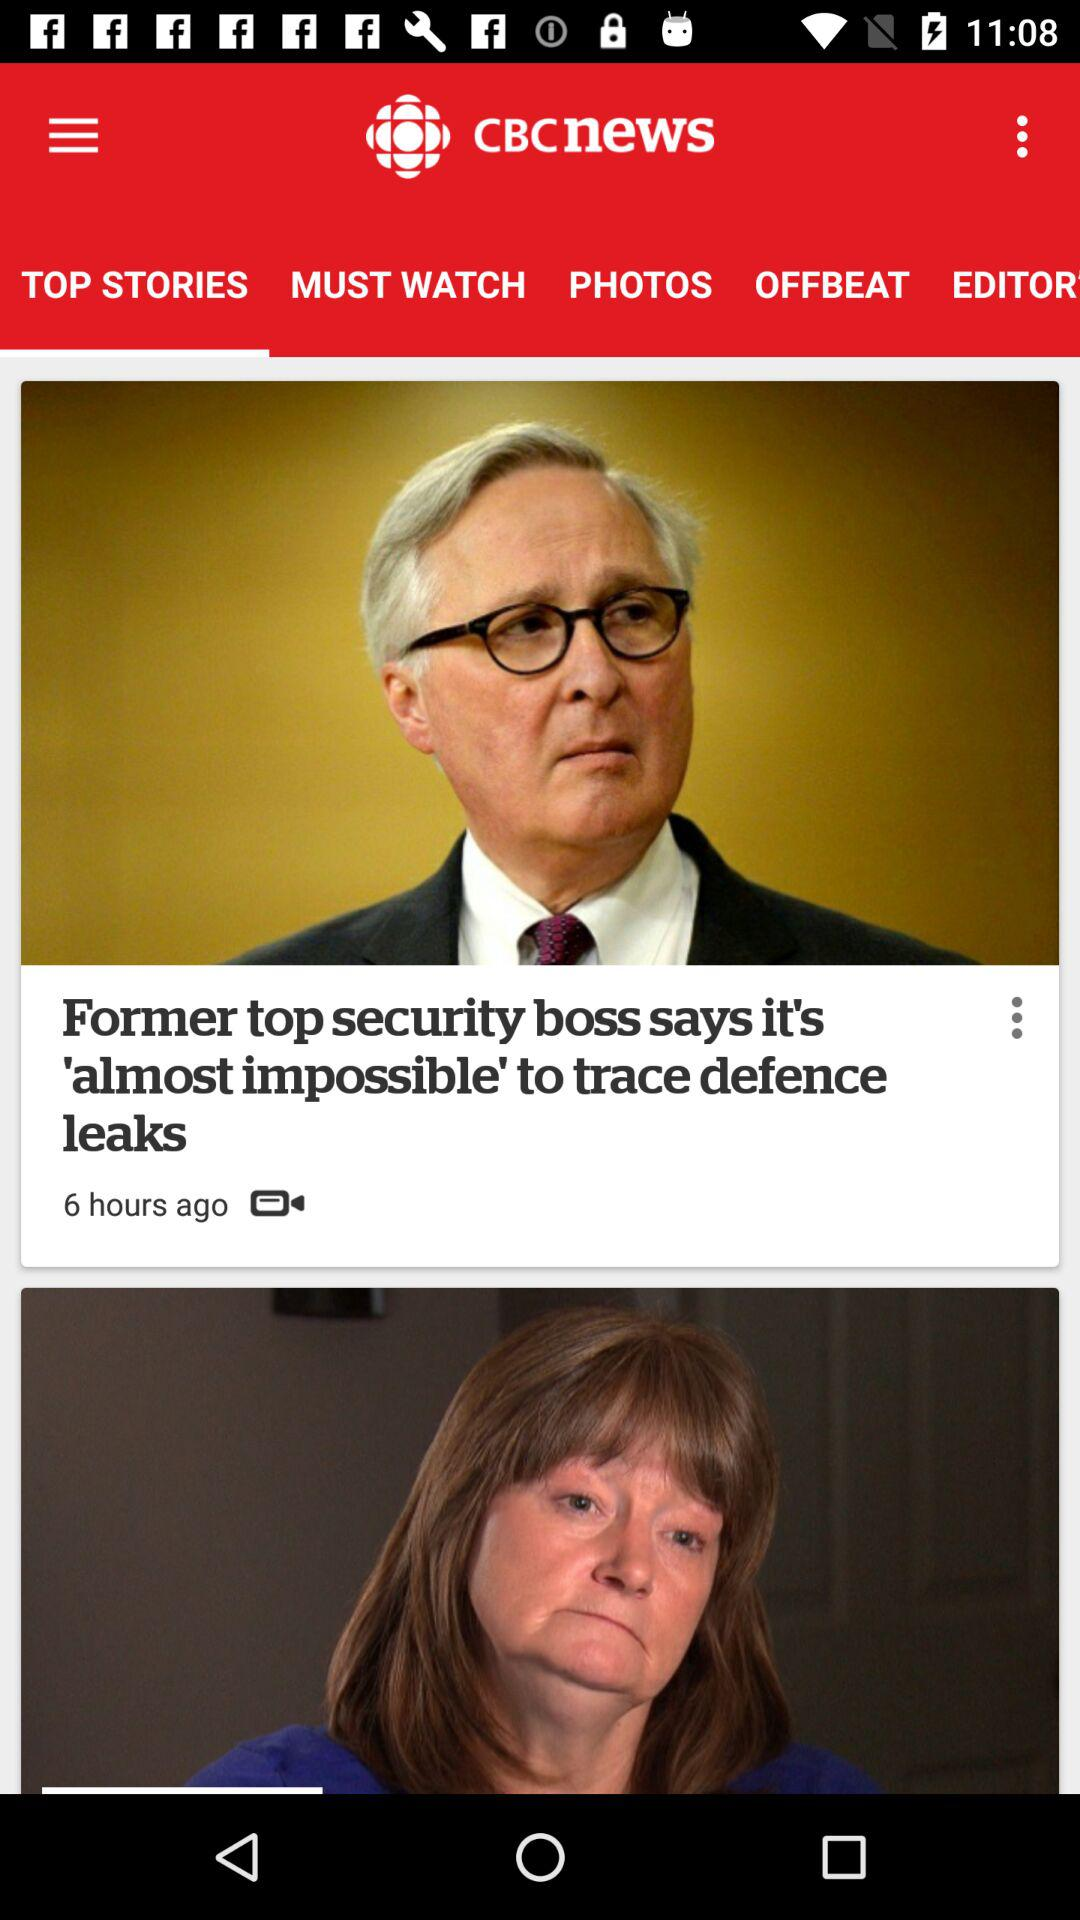What is the title of the news? The title of the news is "Former top security boss says it's 'almost impossible' to trace defence leaks". 